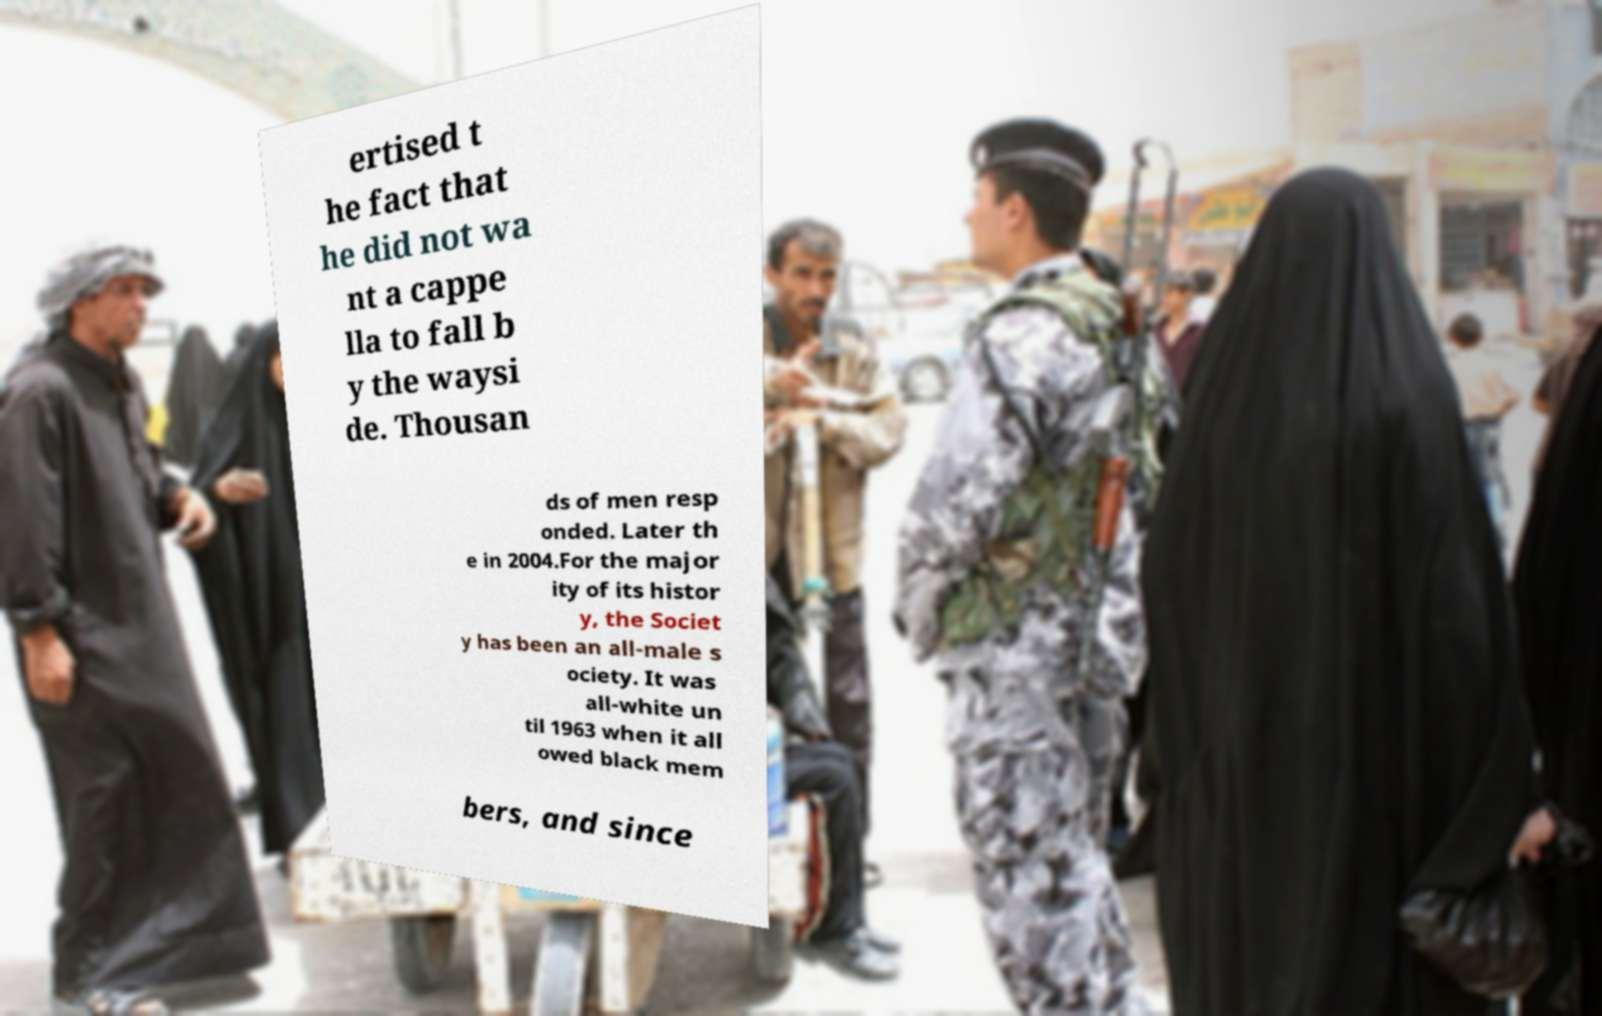There's text embedded in this image that I need extracted. Can you transcribe it verbatim? ertised t he fact that he did not wa nt a cappe lla to fall b y the waysi de. Thousan ds of men resp onded. Later th e in 2004.For the major ity of its histor y, the Societ y has been an all-male s ociety. It was all-white un til 1963 when it all owed black mem bers, and since 